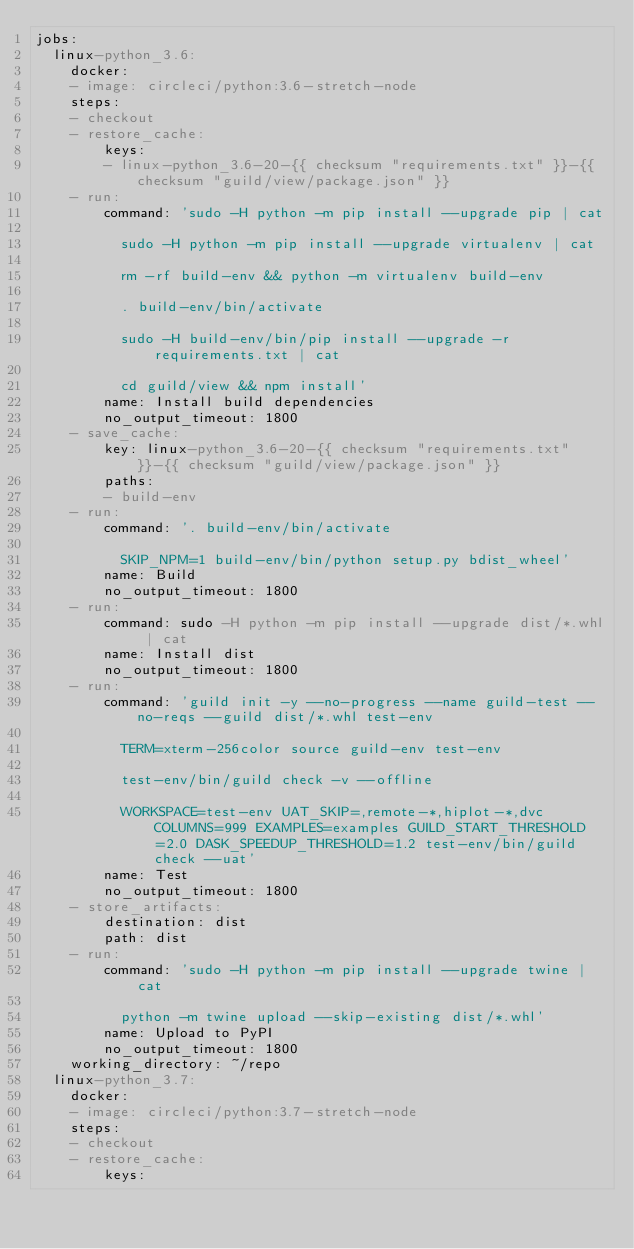Convert code to text. <code><loc_0><loc_0><loc_500><loc_500><_YAML_>jobs:
  linux-python_3.6:
    docker:
    - image: circleci/python:3.6-stretch-node
    steps:
    - checkout
    - restore_cache:
        keys:
        - linux-python_3.6-20-{{ checksum "requirements.txt" }}-{{ checksum "guild/view/package.json" }}
    - run:
        command: 'sudo -H python -m pip install --upgrade pip | cat

          sudo -H python -m pip install --upgrade virtualenv | cat

          rm -rf build-env && python -m virtualenv build-env

          . build-env/bin/activate

          sudo -H build-env/bin/pip install --upgrade -r requirements.txt | cat

          cd guild/view && npm install'
        name: Install build dependencies
        no_output_timeout: 1800
    - save_cache:
        key: linux-python_3.6-20-{{ checksum "requirements.txt" }}-{{ checksum "guild/view/package.json" }}
        paths:
        - build-env
    - run:
        command: '. build-env/bin/activate

          SKIP_NPM=1 build-env/bin/python setup.py bdist_wheel'
        name: Build
        no_output_timeout: 1800
    - run:
        command: sudo -H python -m pip install --upgrade dist/*.whl | cat
        name: Install dist
        no_output_timeout: 1800
    - run:
        command: 'guild init -y --no-progress --name guild-test --no-reqs --guild dist/*.whl test-env

          TERM=xterm-256color source guild-env test-env

          test-env/bin/guild check -v --offline

          WORKSPACE=test-env UAT_SKIP=,remote-*,hiplot-*,dvc COLUMNS=999 EXAMPLES=examples GUILD_START_THRESHOLD=2.0 DASK_SPEEDUP_THRESHOLD=1.2 test-env/bin/guild check --uat'
        name: Test
        no_output_timeout: 1800
    - store_artifacts:
        destination: dist
        path: dist
    - run:
        command: 'sudo -H python -m pip install --upgrade twine | cat

          python -m twine upload --skip-existing dist/*.whl'
        name: Upload to PyPI
        no_output_timeout: 1800
    working_directory: ~/repo
  linux-python_3.7:
    docker:
    - image: circleci/python:3.7-stretch-node
    steps:
    - checkout
    - restore_cache:
        keys:</code> 